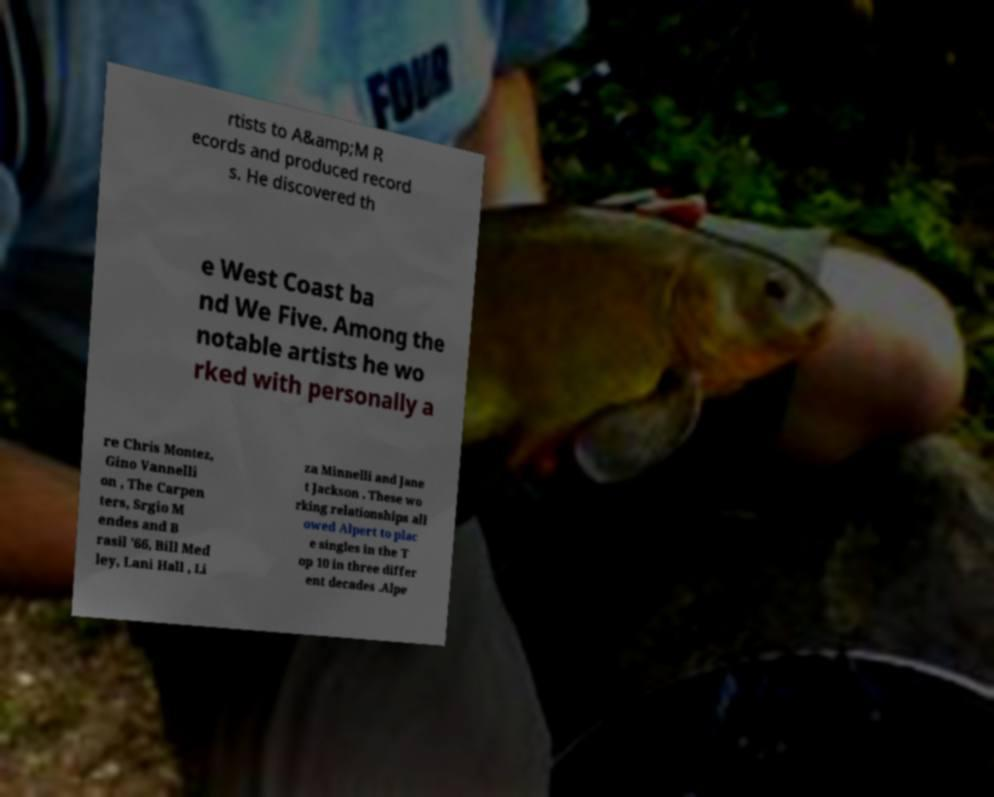Please read and relay the text visible in this image. What does it say? rtists to A&amp;M R ecords and produced record s. He discovered th e West Coast ba nd We Five. Among the notable artists he wo rked with personally a re Chris Montez, Gino Vannelli on , The Carpen ters, Srgio M endes and B rasil '66, Bill Med ley, Lani Hall , Li za Minnelli and Jane t Jackson . These wo rking relationships all owed Alpert to plac e singles in the T op 10 in three differ ent decades .Alpe 